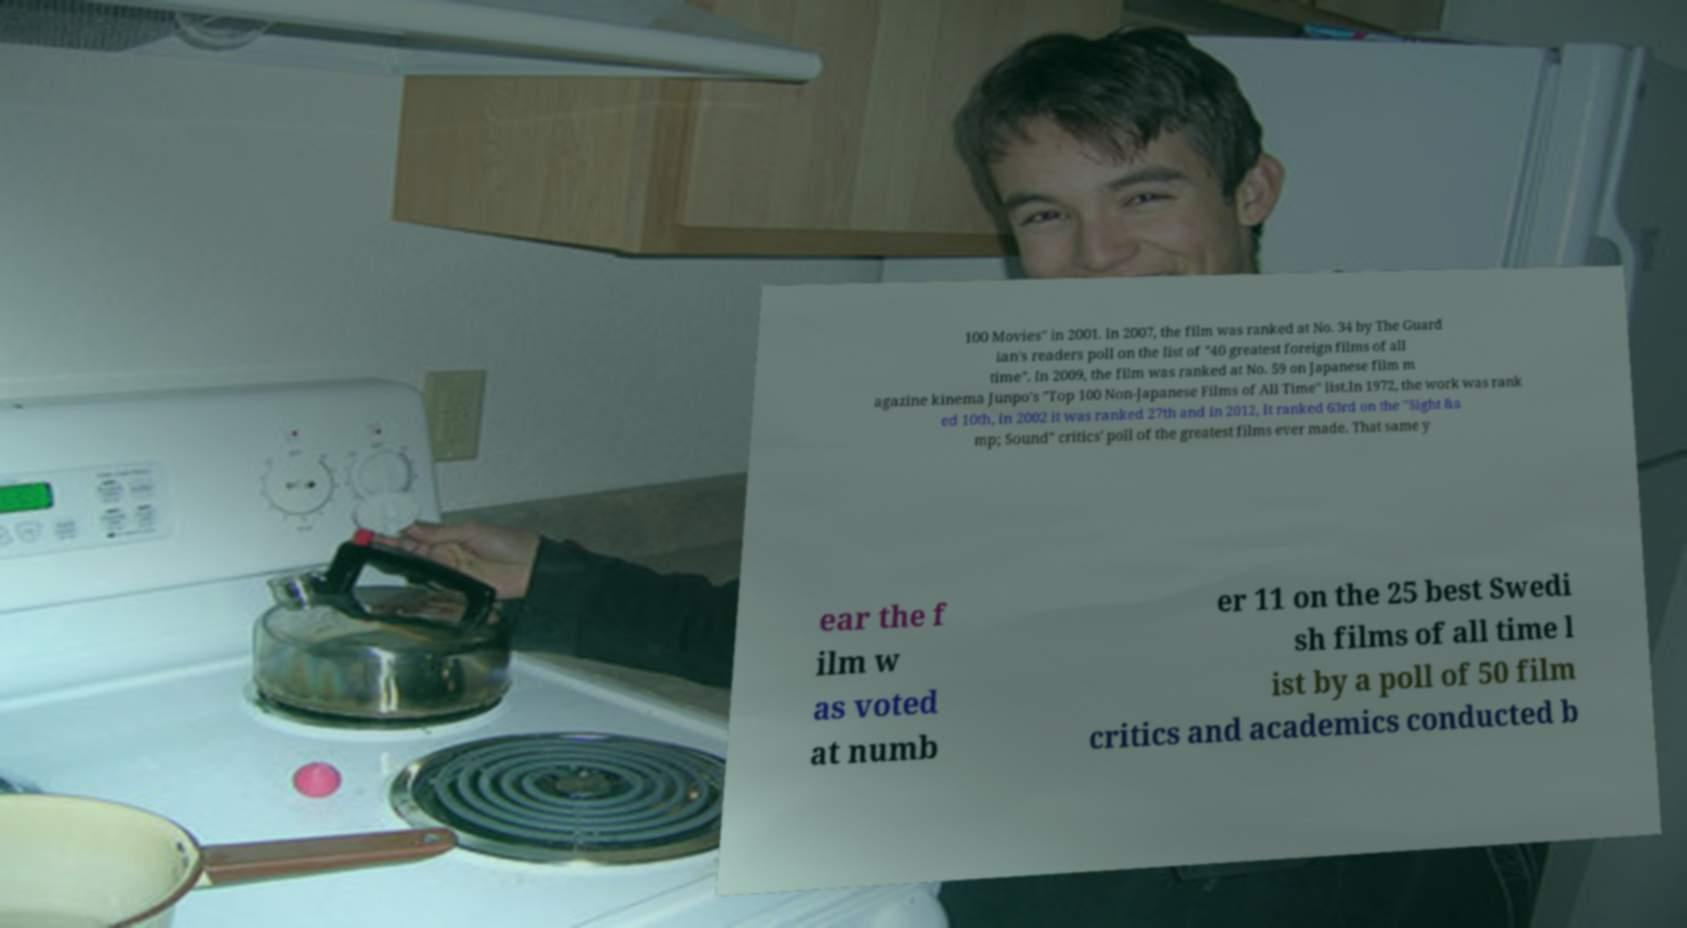For documentation purposes, I need the text within this image transcribed. Could you provide that? 100 Movies" in 2001. In 2007, the film was ranked at No. 34 by The Guard ian's readers poll on the list of "40 greatest foreign films of all time". In 2009, the film was ranked at No. 59 on Japanese film m agazine kinema Junpo's "Top 100 Non-Japanese Films of All Time" list.In 1972, the work was rank ed 10th, in 2002 it was ranked 27th and in 2012, It ranked 63rd on the "Sight &a mp; Sound" critics' poll of the greatest films ever made. That same y ear the f ilm w as voted at numb er 11 on the 25 best Swedi sh films of all time l ist by a poll of 50 film critics and academics conducted b 